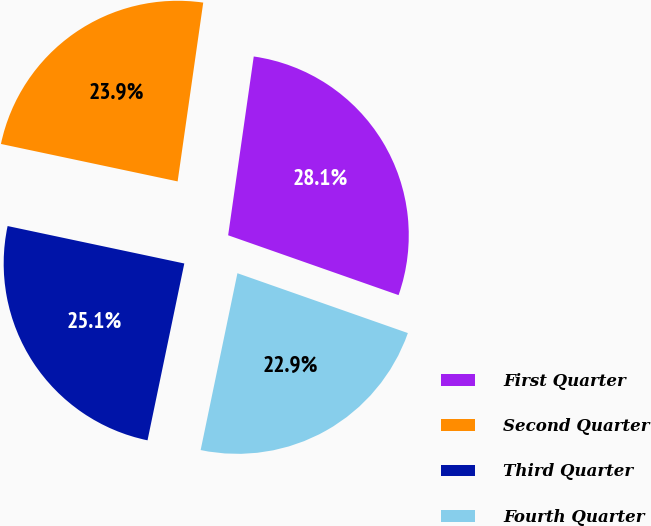Convert chart. <chart><loc_0><loc_0><loc_500><loc_500><pie_chart><fcel>First Quarter<fcel>Second Quarter<fcel>Third Quarter<fcel>Fourth Quarter<nl><fcel>28.11%<fcel>23.94%<fcel>25.06%<fcel>22.89%<nl></chart> 